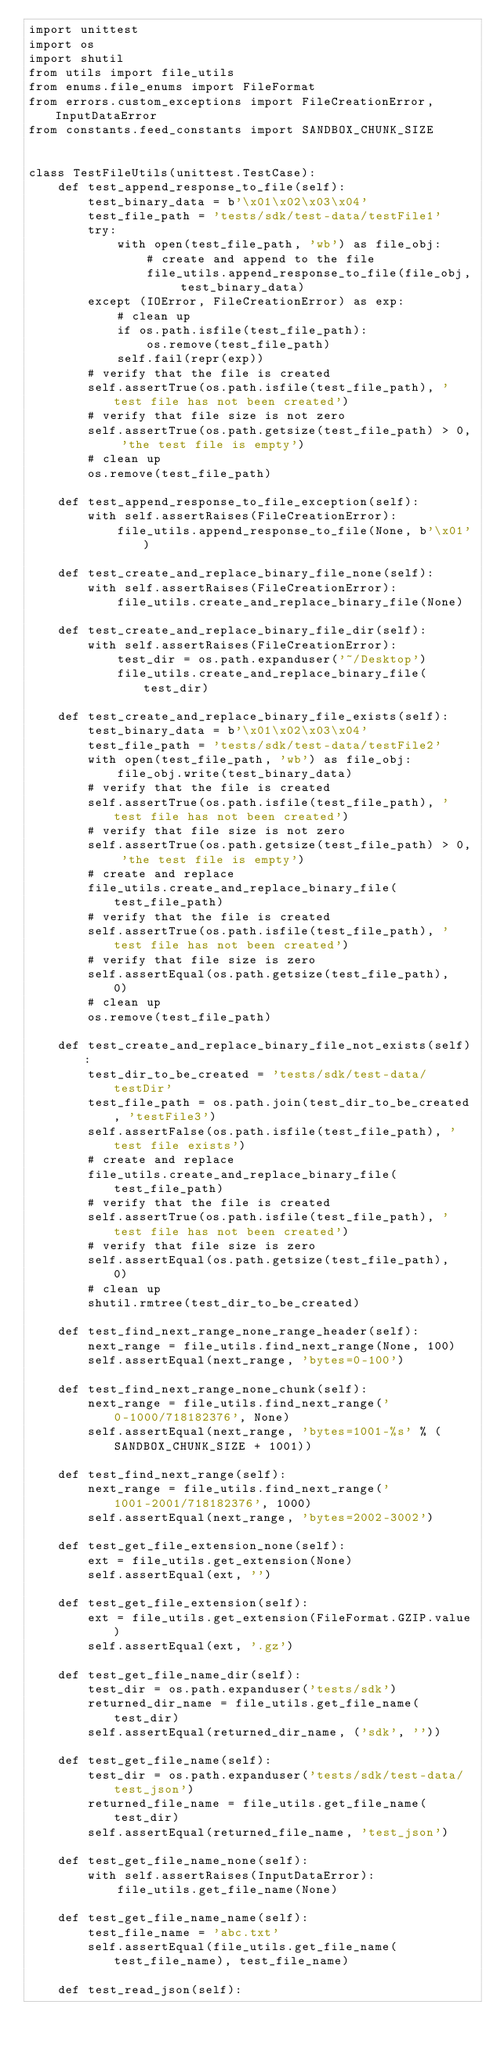Convert code to text. <code><loc_0><loc_0><loc_500><loc_500><_Python_>import unittest
import os
import shutil
from utils import file_utils
from enums.file_enums import FileFormat
from errors.custom_exceptions import FileCreationError, InputDataError
from constants.feed_constants import SANDBOX_CHUNK_SIZE


class TestFileUtils(unittest.TestCase):
    def test_append_response_to_file(self):
        test_binary_data = b'\x01\x02\x03\x04'
        test_file_path = 'tests/sdk/test-data/testFile1'
        try:
            with open(test_file_path, 'wb') as file_obj:
                # create and append to the file
                file_utils.append_response_to_file(file_obj, test_binary_data)
        except (IOError, FileCreationError) as exp:
            # clean up
            if os.path.isfile(test_file_path):
                os.remove(test_file_path)
            self.fail(repr(exp))
        # verify that the file is created
        self.assertTrue(os.path.isfile(test_file_path), 'test file has not been created')
        # verify that file size is not zero
        self.assertTrue(os.path.getsize(test_file_path) > 0, 'the test file is empty')
        # clean up
        os.remove(test_file_path)

    def test_append_response_to_file_exception(self):
        with self.assertRaises(FileCreationError):
            file_utils.append_response_to_file(None, b'\x01')

    def test_create_and_replace_binary_file_none(self):
        with self.assertRaises(FileCreationError):
            file_utils.create_and_replace_binary_file(None)

    def test_create_and_replace_binary_file_dir(self):
        with self.assertRaises(FileCreationError):
            test_dir = os.path.expanduser('~/Desktop')
            file_utils.create_and_replace_binary_file(test_dir)

    def test_create_and_replace_binary_file_exists(self):
        test_binary_data = b'\x01\x02\x03\x04'
        test_file_path = 'tests/sdk/test-data/testFile2'
        with open(test_file_path, 'wb') as file_obj:
            file_obj.write(test_binary_data)
        # verify that the file is created
        self.assertTrue(os.path.isfile(test_file_path), 'test file has not been created')
        # verify that file size is not zero
        self.assertTrue(os.path.getsize(test_file_path) > 0, 'the test file is empty')
        # create and replace
        file_utils.create_and_replace_binary_file(test_file_path)
        # verify that the file is created
        self.assertTrue(os.path.isfile(test_file_path), 'test file has not been created')
        # verify that file size is zero
        self.assertEqual(os.path.getsize(test_file_path),  0)
        # clean up
        os.remove(test_file_path)

    def test_create_and_replace_binary_file_not_exists(self):
        test_dir_to_be_created = 'tests/sdk/test-data/testDir'
        test_file_path = os.path.join(test_dir_to_be_created, 'testFile3')
        self.assertFalse(os.path.isfile(test_file_path), 'test file exists')
        # create and replace
        file_utils.create_and_replace_binary_file(test_file_path)
        # verify that the file is created
        self.assertTrue(os.path.isfile(test_file_path), 'test file has not been created')
        # verify that file size is zero
        self.assertEqual(os.path.getsize(test_file_path),  0)
        # clean up
        shutil.rmtree(test_dir_to_be_created)

    def test_find_next_range_none_range_header(self):
        next_range = file_utils.find_next_range(None, 100)
        self.assertEqual(next_range, 'bytes=0-100')

    def test_find_next_range_none_chunk(self):
        next_range = file_utils.find_next_range('0-1000/718182376', None)
        self.assertEqual(next_range, 'bytes=1001-%s' % (SANDBOX_CHUNK_SIZE + 1001))

    def test_find_next_range(self):
        next_range = file_utils.find_next_range('1001-2001/718182376', 1000)
        self.assertEqual(next_range, 'bytes=2002-3002')

    def test_get_file_extension_none(self):
        ext = file_utils.get_extension(None)
        self.assertEqual(ext, '')

    def test_get_file_extension(self):
        ext = file_utils.get_extension(FileFormat.GZIP.value)
        self.assertEqual(ext, '.gz')

    def test_get_file_name_dir(self):
        test_dir = os.path.expanduser('tests/sdk')
        returned_dir_name = file_utils.get_file_name(test_dir)
        self.assertEqual(returned_dir_name, ('sdk', ''))

    def test_get_file_name(self):
        test_dir = os.path.expanduser('tests/sdk/test-data/test_json')
        returned_file_name = file_utils.get_file_name(test_dir)
        self.assertEqual(returned_file_name, 'test_json')

    def test_get_file_name_none(self):
        with self.assertRaises(InputDataError):
            file_utils.get_file_name(None)

    def test_get_file_name_name(self):
        test_file_name = 'abc.txt'
        self.assertEqual(file_utils.get_file_name(test_file_name), test_file_name)

    def test_read_json(self):</code> 